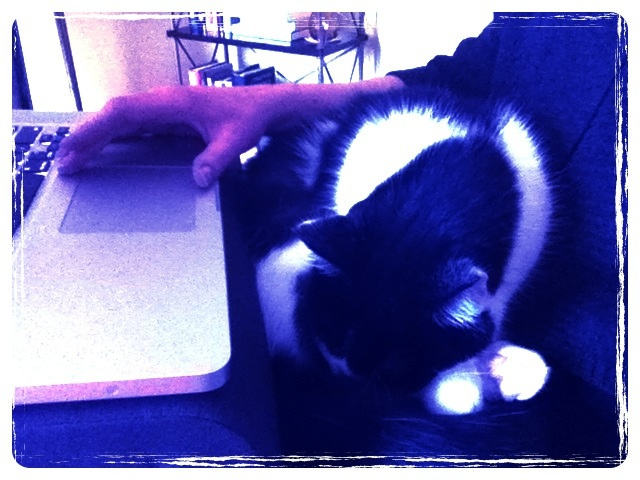Describe the objects in this image and their specific colors. I can see cat in white, navy, and darkblue tones, people in white, navy, darkblue, and blue tones, laptop in white, lavender, blue, and violet tones, book in white, darkblue, blue, and navy tones, and book in white, darkblue, blue, and lavender tones in this image. 